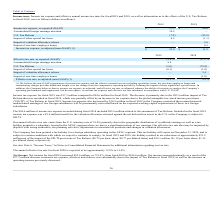From Plexus's financial document, Which years does the table provide information for Income tax expense? The document shows two values: 2019 and 2018. From the document: "2019 2018 2019 2018..." Also, What was the amount of U.S. Tax Reform in 2018? According to the financial document, (85.9) (in millions). The relevant text states: "U.S. Tax Reform (7.0) (85.9)..." Also, What was the Impact of one-time employee bonus in 2018? According to the financial document, 0.3 (in millions). The relevant text states: "Impact of one-time employee bonus — 0.3..." Also, How many years did Income tax expense, as reported (GAAP) exceed $50 million? Based on the analysis, there are 1 instances. The counting process: 2018. Also, can you calculate: What was the change in the Impact of other special tax items between 2018 and 2019? Based on the calculation: 0.2-(-1.1), the result is 1.3 (in millions). This is based on the information: "Impact of other special tax items 0.2 (1.1) Impact of other special tax items 0.2 (1.1)..." The key data points involved are: 0.2, 1.1. Also, can you calculate: What was the percentage change in the Income tax expense, as adjusted (non-GAAP) between 2018 and 2019? To answer this question, I need to perform calculations using the financial data. The calculation is: (21.0-11.5)/11.5, which equals 82.61 (percentage). This is based on the information: "Income tax expense, as adjusted (non-GAAP) (1) $ 21.0 $ 11.5 tax expense, as adjusted (non-GAAP) (1) $ 21.0 $ 11.5..." The key data points involved are: 11.5, 21.0. 